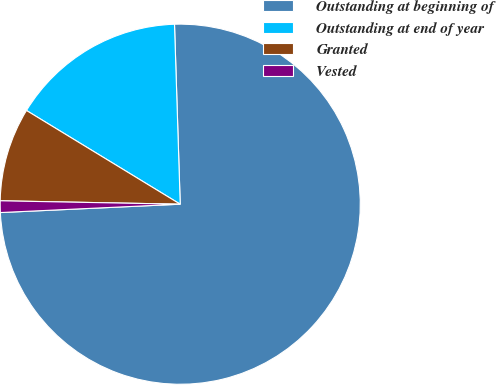Convert chart to OTSL. <chart><loc_0><loc_0><loc_500><loc_500><pie_chart><fcel>Outstanding at beginning of<fcel>Outstanding at end of year<fcel>Granted<fcel>Vested<nl><fcel>74.76%<fcel>15.78%<fcel>8.41%<fcel>1.04%<nl></chart> 